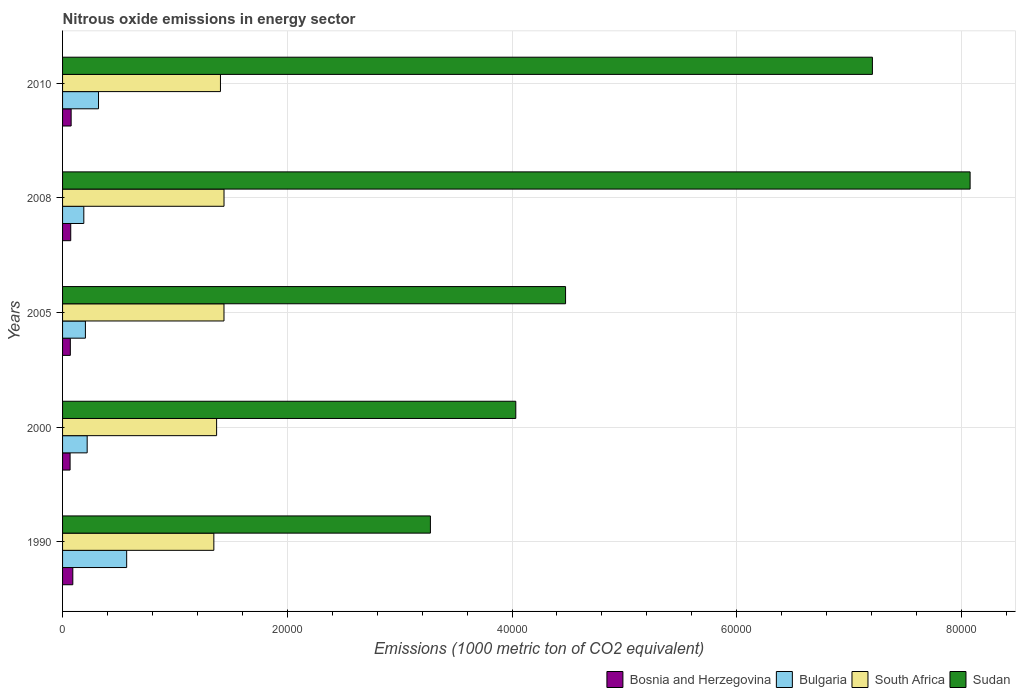Are the number of bars per tick equal to the number of legend labels?
Give a very brief answer. Yes. In how many cases, is the number of bars for a given year not equal to the number of legend labels?
Keep it short and to the point. 0. What is the amount of nitrous oxide emitted in Bosnia and Herzegovina in 2000?
Make the answer very short. 669.3. Across all years, what is the maximum amount of nitrous oxide emitted in Bulgaria?
Provide a succinct answer. 5705.4. Across all years, what is the minimum amount of nitrous oxide emitted in South Africa?
Keep it short and to the point. 1.35e+04. In which year was the amount of nitrous oxide emitted in South Africa maximum?
Ensure brevity in your answer.  2008. What is the total amount of nitrous oxide emitted in South Africa in the graph?
Ensure brevity in your answer.  7.00e+04. What is the difference between the amount of nitrous oxide emitted in Sudan in 1990 and that in 2000?
Offer a terse response. -7600.6. What is the difference between the amount of nitrous oxide emitted in South Africa in 1990 and the amount of nitrous oxide emitted in Sudan in 2005?
Your answer should be very brief. -3.13e+04. What is the average amount of nitrous oxide emitted in South Africa per year?
Provide a short and direct response. 1.40e+04. In the year 1990, what is the difference between the amount of nitrous oxide emitted in South Africa and amount of nitrous oxide emitted in Sudan?
Keep it short and to the point. -1.93e+04. In how many years, is the amount of nitrous oxide emitted in Sudan greater than 64000 1000 metric ton?
Give a very brief answer. 2. What is the ratio of the amount of nitrous oxide emitted in South Africa in 1990 to that in 2005?
Give a very brief answer. 0.94. What is the difference between the highest and the second highest amount of nitrous oxide emitted in Sudan?
Give a very brief answer. 8696.2. What is the difference between the highest and the lowest amount of nitrous oxide emitted in Bosnia and Herzegovina?
Your response must be concise. 242.9. Is the sum of the amount of nitrous oxide emitted in Bulgaria in 2008 and 2010 greater than the maximum amount of nitrous oxide emitted in Sudan across all years?
Your answer should be compact. No. What does the 2nd bar from the top in 2000 represents?
Provide a short and direct response. South Africa. How many bars are there?
Offer a terse response. 20. How many years are there in the graph?
Provide a succinct answer. 5. What is the difference between two consecutive major ticks on the X-axis?
Offer a very short reply. 2.00e+04. Are the values on the major ticks of X-axis written in scientific E-notation?
Make the answer very short. No. Does the graph contain any zero values?
Offer a terse response. No. Does the graph contain grids?
Give a very brief answer. Yes. How many legend labels are there?
Your answer should be very brief. 4. How are the legend labels stacked?
Give a very brief answer. Horizontal. What is the title of the graph?
Give a very brief answer. Nitrous oxide emissions in energy sector. What is the label or title of the X-axis?
Offer a very short reply. Emissions (1000 metric ton of CO2 equivalent). What is the Emissions (1000 metric ton of CO2 equivalent) of Bosnia and Herzegovina in 1990?
Make the answer very short. 912.2. What is the Emissions (1000 metric ton of CO2 equivalent) of Bulgaria in 1990?
Provide a succinct answer. 5705.4. What is the Emissions (1000 metric ton of CO2 equivalent) in South Africa in 1990?
Make the answer very short. 1.35e+04. What is the Emissions (1000 metric ton of CO2 equivalent) in Sudan in 1990?
Ensure brevity in your answer.  3.27e+04. What is the Emissions (1000 metric ton of CO2 equivalent) of Bosnia and Herzegovina in 2000?
Ensure brevity in your answer.  669.3. What is the Emissions (1000 metric ton of CO2 equivalent) of Bulgaria in 2000?
Provide a succinct answer. 2189.9. What is the Emissions (1000 metric ton of CO2 equivalent) in South Africa in 2000?
Offer a very short reply. 1.37e+04. What is the Emissions (1000 metric ton of CO2 equivalent) of Sudan in 2000?
Provide a short and direct response. 4.03e+04. What is the Emissions (1000 metric ton of CO2 equivalent) in Bosnia and Herzegovina in 2005?
Your response must be concise. 691.3. What is the Emissions (1000 metric ton of CO2 equivalent) of Bulgaria in 2005?
Give a very brief answer. 2033.5. What is the Emissions (1000 metric ton of CO2 equivalent) of South Africa in 2005?
Your answer should be very brief. 1.44e+04. What is the Emissions (1000 metric ton of CO2 equivalent) in Sudan in 2005?
Your response must be concise. 4.48e+04. What is the Emissions (1000 metric ton of CO2 equivalent) in Bosnia and Herzegovina in 2008?
Make the answer very short. 727.1. What is the Emissions (1000 metric ton of CO2 equivalent) of Bulgaria in 2008?
Offer a terse response. 1890.6. What is the Emissions (1000 metric ton of CO2 equivalent) in South Africa in 2008?
Provide a succinct answer. 1.44e+04. What is the Emissions (1000 metric ton of CO2 equivalent) of Sudan in 2008?
Your answer should be compact. 8.08e+04. What is the Emissions (1000 metric ton of CO2 equivalent) in Bosnia and Herzegovina in 2010?
Offer a very short reply. 762.6. What is the Emissions (1000 metric ton of CO2 equivalent) in Bulgaria in 2010?
Make the answer very short. 3199.8. What is the Emissions (1000 metric ton of CO2 equivalent) in South Africa in 2010?
Offer a terse response. 1.41e+04. What is the Emissions (1000 metric ton of CO2 equivalent) of Sudan in 2010?
Give a very brief answer. 7.21e+04. Across all years, what is the maximum Emissions (1000 metric ton of CO2 equivalent) of Bosnia and Herzegovina?
Offer a terse response. 912.2. Across all years, what is the maximum Emissions (1000 metric ton of CO2 equivalent) in Bulgaria?
Your answer should be very brief. 5705.4. Across all years, what is the maximum Emissions (1000 metric ton of CO2 equivalent) of South Africa?
Keep it short and to the point. 1.44e+04. Across all years, what is the maximum Emissions (1000 metric ton of CO2 equivalent) of Sudan?
Ensure brevity in your answer.  8.08e+04. Across all years, what is the minimum Emissions (1000 metric ton of CO2 equivalent) in Bosnia and Herzegovina?
Give a very brief answer. 669.3. Across all years, what is the minimum Emissions (1000 metric ton of CO2 equivalent) of Bulgaria?
Provide a succinct answer. 1890.6. Across all years, what is the minimum Emissions (1000 metric ton of CO2 equivalent) in South Africa?
Your answer should be very brief. 1.35e+04. Across all years, what is the minimum Emissions (1000 metric ton of CO2 equivalent) of Sudan?
Your answer should be compact. 3.27e+04. What is the total Emissions (1000 metric ton of CO2 equivalent) of Bosnia and Herzegovina in the graph?
Provide a succinct answer. 3762.5. What is the total Emissions (1000 metric ton of CO2 equivalent) in Bulgaria in the graph?
Give a very brief answer. 1.50e+04. What is the total Emissions (1000 metric ton of CO2 equivalent) in South Africa in the graph?
Provide a short and direct response. 7.00e+04. What is the total Emissions (1000 metric ton of CO2 equivalent) of Sudan in the graph?
Make the answer very short. 2.71e+05. What is the difference between the Emissions (1000 metric ton of CO2 equivalent) in Bosnia and Herzegovina in 1990 and that in 2000?
Provide a short and direct response. 242.9. What is the difference between the Emissions (1000 metric ton of CO2 equivalent) of Bulgaria in 1990 and that in 2000?
Your answer should be very brief. 3515.5. What is the difference between the Emissions (1000 metric ton of CO2 equivalent) in South Africa in 1990 and that in 2000?
Offer a very short reply. -246.5. What is the difference between the Emissions (1000 metric ton of CO2 equivalent) in Sudan in 1990 and that in 2000?
Offer a very short reply. -7600.6. What is the difference between the Emissions (1000 metric ton of CO2 equivalent) in Bosnia and Herzegovina in 1990 and that in 2005?
Offer a very short reply. 220.9. What is the difference between the Emissions (1000 metric ton of CO2 equivalent) in Bulgaria in 1990 and that in 2005?
Give a very brief answer. 3671.9. What is the difference between the Emissions (1000 metric ton of CO2 equivalent) in South Africa in 1990 and that in 2005?
Give a very brief answer. -903.7. What is the difference between the Emissions (1000 metric ton of CO2 equivalent) in Sudan in 1990 and that in 2005?
Offer a terse response. -1.20e+04. What is the difference between the Emissions (1000 metric ton of CO2 equivalent) in Bosnia and Herzegovina in 1990 and that in 2008?
Your answer should be very brief. 185.1. What is the difference between the Emissions (1000 metric ton of CO2 equivalent) of Bulgaria in 1990 and that in 2008?
Provide a succinct answer. 3814.8. What is the difference between the Emissions (1000 metric ton of CO2 equivalent) in South Africa in 1990 and that in 2008?
Offer a terse response. -905.7. What is the difference between the Emissions (1000 metric ton of CO2 equivalent) of Sudan in 1990 and that in 2008?
Your answer should be very brief. -4.80e+04. What is the difference between the Emissions (1000 metric ton of CO2 equivalent) of Bosnia and Herzegovina in 1990 and that in 2010?
Keep it short and to the point. 149.6. What is the difference between the Emissions (1000 metric ton of CO2 equivalent) in Bulgaria in 1990 and that in 2010?
Your response must be concise. 2505.6. What is the difference between the Emissions (1000 metric ton of CO2 equivalent) of South Africa in 1990 and that in 2010?
Keep it short and to the point. -588.2. What is the difference between the Emissions (1000 metric ton of CO2 equivalent) of Sudan in 1990 and that in 2010?
Provide a short and direct response. -3.93e+04. What is the difference between the Emissions (1000 metric ton of CO2 equivalent) in Bulgaria in 2000 and that in 2005?
Provide a succinct answer. 156.4. What is the difference between the Emissions (1000 metric ton of CO2 equivalent) in South Africa in 2000 and that in 2005?
Your response must be concise. -657.2. What is the difference between the Emissions (1000 metric ton of CO2 equivalent) of Sudan in 2000 and that in 2005?
Your response must be concise. -4429.1. What is the difference between the Emissions (1000 metric ton of CO2 equivalent) of Bosnia and Herzegovina in 2000 and that in 2008?
Offer a very short reply. -57.8. What is the difference between the Emissions (1000 metric ton of CO2 equivalent) of Bulgaria in 2000 and that in 2008?
Your response must be concise. 299.3. What is the difference between the Emissions (1000 metric ton of CO2 equivalent) of South Africa in 2000 and that in 2008?
Offer a terse response. -659.2. What is the difference between the Emissions (1000 metric ton of CO2 equivalent) of Sudan in 2000 and that in 2008?
Offer a very short reply. -4.04e+04. What is the difference between the Emissions (1000 metric ton of CO2 equivalent) in Bosnia and Herzegovina in 2000 and that in 2010?
Your response must be concise. -93.3. What is the difference between the Emissions (1000 metric ton of CO2 equivalent) of Bulgaria in 2000 and that in 2010?
Your response must be concise. -1009.9. What is the difference between the Emissions (1000 metric ton of CO2 equivalent) of South Africa in 2000 and that in 2010?
Provide a short and direct response. -341.7. What is the difference between the Emissions (1000 metric ton of CO2 equivalent) of Sudan in 2000 and that in 2010?
Ensure brevity in your answer.  -3.17e+04. What is the difference between the Emissions (1000 metric ton of CO2 equivalent) of Bosnia and Herzegovina in 2005 and that in 2008?
Ensure brevity in your answer.  -35.8. What is the difference between the Emissions (1000 metric ton of CO2 equivalent) of Bulgaria in 2005 and that in 2008?
Ensure brevity in your answer.  142.9. What is the difference between the Emissions (1000 metric ton of CO2 equivalent) of South Africa in 2005 and that in 2008?
Keep it short and to the point. -2. What is the difference between the Emissions (1000 metric ton of CO2 equivalent) of Sudan in 2005 and that in 2008?
Ensure brevity in your answer.  -3.60e+04. What is the difference between the Emissions (1000 metric ton of CO2 equivalent) in Bosnia and Herzegovina in 2005 and that in 2010?
Provide a succinct answer. -71.3. What is the difference between the Emissions (1000 metric ton of CO2 equivalent) in Bulgaria in 2005 and that in 2010?
Your answer should be very brief. -1166.3. What is the difference between the Emissions (1000 metric ton of CO2 equivalent) of South Africa in 2005 and that in 2010?
Your response must be concise. 315.5. What is the difference between the Emissions (1000 metric ton of CO2 equivalent) of Sudan in 2005 and that in 2010?
Your answer should be compact. -2.73e+04. What is the difference between the Emissions (1000 metric ton of CO2 equivalent) of Bosnia and Herzegovina in 2008 and that in 2010?
Give a very brief answer. -35.5. What is the difference between the Emissions (1000 metric ton of CO2 equivalent) of Bulgaria in 2008 and that in 2010?
Give a very brief answer. -1309.2. What is the difference between the Emissions (1000 metric ton of CO2 equivalent) in South Africa in 2008 and that in 2010?
Provide a short and direct response. 317.5. What is the difference between the Emissions (1000 metric ton of CO2 equivalent) in Sudan in 2008 and that in 2010?
Your answer should be very brief. 8696.2. What is the difference between the Emissions (1000 metric ton of CO2 equivalent) in Bosnia and Herzegovina in 1990 and the Emissions (1000 metric ton of CO2 equivalent) in Bulgaria in 2000?
Offer a terse response. -1277.7. What is the difference between the Emissions (1000 metric ton of CO2 equivalent) in Bosnia and Herzegovina in 1990 and the Emissions (1000 metric ton of CO2 equivalent) in South Africa in 2000?
Keep it short and to the point. -1.28e+04. What is the difference between the Emissions (1000 metric ton of CO2 equivalent) in Bosnia and Herzegovina in 1990 and the Emissions (1000 metric ton of CO2 equivalent) in Sudan in 2000?
Your answer should be very brief. -3.94e+04. What is the difference between the Emissions (1000 metric ton of CO2 equivalent) of Bulgaria in 1990 and the Emissions (1000 metric ton of CO2 equivalent) of South Africa in 2000?
Make the answer very short. -8004.5. What is the difference between the Emissions (1000 metric ton of CO2 equivalent) in Bulgaria in 1990 and the Emissions (1000 metric ton of CO2 equivalent) in Sudan in 2000?
Your response must be concise. -3.46e+04. What is the difference between the Emissions (1000 metric ton of CO2 equivalent) in South Africa in 1990 and the Emissions (1000 metric ton of CO2 equivalent) in Sudan in 2000?
Keep it short and to the point. -2.69e+04. What is the difference between the Emissions (1000 metric ton of CO2 equivalent) of Bosnia and Herzegovina in 1990 and the Emissions (1000 metric ton of CO2 equivalent) of Bulgaria in 2005?
Ensure brevity in your answer.  -1121.3. What is the difference between the Emissions (1000 metric ton of CO2 equivalent) in Bosnia and Herzegovina in 1990 and the Emissions (1000 metric ton of CO2 equivalent) in South Africa in 2005?
Your answer should be very brief. -1.35e+04. What is the difference between the Emissions (1000 metric ton of CO2 equivalent) in Bosnia and Herzegovina in 1990 and the Emissions (1000 metric ton of CO2 equivalent) in Sudan in 2005?
Offer a very short reply. -4.39e+04. What is the difference between the Emissions (1000 metric ton of CO2 equivalent) of Bulgaria in 1990 and the Emissions (1000 metric ton of CO2 equivalent) of South Africa in 2005?
Give a very brief answer. -8661.7. What is the difference between the Emissions (1000 metric ton of CO2 equivalent) of Bulgaria in 1990 and the Emissions (1000 metric ton of CO2 equivalent) of Sudan in 2005?
Your answer should be very brief. -3.91e+04. What is the difference between the Emissions (1000 metric ton of CO2 equivalent) of South Africa in 1990 and the Emissions (1000 metric ton of CO2 equivalent) of Sudan in 2005?
Keep it short and to the point. -3.13e+04. What is the difference between the Emissions (1000 metric ton of CO2 equivalent) of Bosnia and Herzegovina in 1990 and the Emissions (1000 metric ton of CO2 equivalent) of Bulgaria in 2008?
Your answer should be very brief. -978.4. What is the difference between the Emissions (1000 metric ton of CO2 equivalent) in Bosnia and Herzegovina in 1990 and the Emissions (1000 metric ton of CO2 equivalent) in South Africa in 2008?
Provide a succinct answer. -1.35e+04. What is the difference between the Emissions (1000 metric ton of CO2 equivalent) of Bosnia and Herzegovina in 1990 and the Emissions (1000 metric ton of CO2 equivalent) of Sudan in 2008?
Give a very brief answer. -7.99e+04. What is the difference between the Emissions (1000 metric ton of CO2 equivalent) in Bulgaria in 1990 and the Emissions (1000 metric ton of CO2 equivalent) in South Africa in 2008?
Offer a terse response. -8663.7. What is the difference between the Emissions (1000 metric ton of CO2 equivalent) in Bulgaria in 1990 and the Emissions (1000 metric ton of CO2 equivalent) in Sudan in 2008?
Your answer should be compact. -7.51e+04. What is the difference between the Emissions (1000 metric ton of CO2 equivalent) of South Africa in 1990 and the Emissions (1000 metric ton of CO2 equivalent) of Sudan in 2008?
Provide a succinct answer. -6.73e+04. What is the difference between the Emissions (1000 metric ton of CO2 equivalent) in Bosnia and Herzegovina in 1990 and the Emissions (1000 metric ton of CO2 equivalent) in Bulgaria in 2010?
Give a very brief answer. -2287.6. What is the difference between the Emissions (1000 metric ton of CO2 equivalent) in Bosnia and Herzegovina in 1990 and the Emissions (1000 metric ton of CO2 equivalent) in South Africa in 2010?
Provide a succinct answer. -1.31e+04. What is the difference between the Emissions (1000 metric ton of CO2 equivalent) of Bosnia and Herzegovina in 1990 and the Emissions (1000 metric ton of CO2 equivalent) of Sudan in 2010?
Your answer should be compact. -7.12e+04. What is the difference between the Emissions (1000 metric ton of CO2 equivalent) of Bulgaria in 1990 and the Emissions (1000 metric ton of CO2 equivalent) of South Africa in 2010?
Provide a short and direct response. -8346.2. What is the difference between the Emissions (1000 metric ton of CO2 equivalent) of Bulgaria in 1990 and the Emissions (1000 metric ton of CO2 equivalent) of Sudan in 2010?
Your answer should be very brief. -6.64e+04. What is the difference between the Emissions (1000 metric ton of CO2 equivalent) in South Africa in 1990 and the Emissions (1000 metric ton of CO2 equivalent) in Sudan in 2010?
Your response must be concise. -5.86e+04. What is the difference between the Emissions (1000 metric ton of CO2 equivalent) in Bosnia and Herzegovina in 2000 and the Emissions (1000 metric ton of CO2 equivalent) in Bulgaria in 2005?
Your response must be concise. -1364.2. What is the difference between the Emissions (1000 metric ton of CO2 equivalent) in Bosnia and Herzegovina in 2000 and the Emissions (1000 metric ton of CO2 equivalent) in South Africa in 2005?
Your answer should be compact. -1.37e+04. What is the difference between the Emissions (1000 metric ton of CO2 equivalent) of Bosnia and Herzegovina in 2000 and the Emissions (1000 metric ton of CO2 equivalent) of Sudan in 2005?
Offer a very short reply. -4.41e+04. What is the difference between the Emissions (1000 metric ton of CO2 equivalent) of Bulgaria in 2000 and the Emissions (1000 metric ton of CO2 equivalent) of South Africa in 2005?
Make the answer very short. -1.22e+04. What is the difference between the Emissions (1000 metric ton of CO2 equivalent) of Bulgaria in 2000 and the Emissions (1000 metric ton of CO2 equivalent) of Sudan in 2005?
Provide a succinct answer. -4.26e+04. What is the difference between the Emissions (1000 metric ton of CO2 equivalent) of South Africa in 2000 and the Emissions (1000 metric ton of CO2 equivalent) of Sudan in 2005?
Provide a short and direct response. -3.11e+04. What is the difference between the Emissions (1000 metric ton of CO2 equivalent) in Bosnia and Herzegovina in 2000 and the Emissions (1000 metric ton of CO2 equivalent) in Bulgaria in 2008?
Provide a succinct answer. -1221.3. What is the difference between the Emissions (1000 metric ton of CO2 equivalent) in Bosnia and Herzegovina in 2000 and the Emissions (1000 metric ton of CO2 equivalent) in South Africa in 2008?
Your answer should be compact. -1.37e+04. What is the difference between the Emissions (1000 metric ton of CO2 equivalent) of Bosnia and Herzegovina in 2000 and the Emissions (1000 metric ton of CO2 equivalent) of Sudan in 2008?
Offer a very short reply. -8.01e+04. What is the difference between the Emissions (1000 metric ton of CO2 equivalent) in Bulgaria in 2000 and the Emissions (1000 metric ton of CO2 equivalent) in South Africa in 2008?
Ensure brevity in your answer.  -1.22e+04. What is the difference between the Emissions (1000 metric ton of CO2 equivalent) in Bulgaria in 2000 and the Emissions (1000 metric ton of CO2 equivalent) in Sudan in 2008?
Keep it short and to the point. -7.86e+04. What is the difference between the Emissions (1000 metric ton of CO2 equivalent) in South Africa in 2000 and the Emissions (1000 metric ton of CO2 equivalent) in Sudan in 2008?
Offer a very short reply. -6.71e+04. What is the difference between the Emissions (1000 metric ton of CO2 equivalent) of Bosnia and Herzegovina in 2000 and the Emissions (1000 metric ton of CO2 equivalent) of Bulgaria in 2010?
Provide a succinct answer. -2530.5. What is the difference between the Emissions (1000 metric ton of CO2 equivalent) in Bosnia and Herzegovina in 2000 and the Emissions (1000 metric ton of CO2 equivalent) in South Africa in 2010?
Keep it short and to the point. -1.34e+04. What is the difference between the Emissions (1000 metric ton of CO2 equivalent) of Bosnia and Herzegovina in 2000 and the Emissions (1000 metric ton of CO2 equivalent) of Sudan in 2010?
Your response must be concise. -7.14e+04. What is the difference between the Emissions (1000 metric ton of CO2 equivalent) in Bulgaria in 2000 and the Emissions (1000 metric ton of CO2 equivalent) in South Africa in 2010?
Make the answer very short. -1.19e+04. What is the difference between the Emissions (1000 metric ton of CO2 equivalent) in Bulgaria in 2000 and the Emissions (1000 metric ton of CO2 equivalent) in Sudan in 2010?
Make the answer very short. -6.99e+04. What is the difference between the Emissions (1000 metric ton of CO2 equivalent) of South Africa in 2000 and the Emissions (1000 metric ton of CO2 equivalent) of Sudan in 2010?
Your answer should be very brief. -5.84e+04. What is the difference between the Emissions (1000 metric ton of CO2 equivalent) in Bosnia and Herzegovina in 2005 and the Emissions (1000 metric ton of CO2 equivalent) in Bulgaria in 2008?
Provide a succinct answer. -1199.3. What is the difference between the Emissions (1000 metric ton of CO2 equivalent) in Bosnia and Herzegovina in 2005 and the Emissions (1000 metric ton of CO2 equivalent) in South Africa in 2008?
Keep it short and to the point. -1.37e+04. What is the difference between the Emissions (1000 metric ton of CO2 equivalent) of Bosnia and Herzegovina in 2005 and the Emissions (1000 metric ton of CO2 equivalent) of Sudan in 2008?
Offer a terse response. -8.01e+04. What is the difference between the Emissions (1000 metric ton of CO2 equivalent) in Bulgaria in 2005 and the Emissions (1000 metric ton of CO2 equivalent) in South Africa in 2008?
Provide a short and direct response. -1.23e+04. What is the difference between the Emissions (1000 metric ton of CO2 equivalent) in Bulgaria in 2005 and the Emissions (1000 metric ton of CO2 equivalent) in Sudan in 2008?
Offer a terse response. -7.87e+04. What is the difference between the Emissions (1000 metric ton of CO2 equivalent) in South Africa in 2005 and the Emissions (1000 metric ton of CO2 equivalent) in Sudan in 2008?
Provide a succinct answer. -6.64e+04. What is the difference between the Emissions (1000 metric ton of CO2 equivalent) in Bosnia and Herzegovina in 2005 and the Emissions (1000 metric ton of CO2 equivalent) in Bulgaria in 2010?
Make the answer very short. -2508.5. What is the difference between the Emissions (1000 metric ton of CO2 equivalent) in Bosnia and Herzegovina in 2005 and the Emissions (1000 metric ton of CO2 equivalent) in South Africa in 2010?
Offer a terse response. -1.34e+04. What is the difference between the Emissions (1000 metric ton of CO2 equivalent) in Bosnia and Herzegovina in 2005 and the Emissions (1000 metric ton of CO2 equivalent) in Sudan in 2010?
Offer a very short reply. -7.14e+04. What is the difference between the Emissions (1000 metric ton of CO2 equivalent) in Bulgaria in 2005 and the Emissions (1000 metric ton of CO2 equivalent) in South Africa in 2010?
Your answer should be compact. -1.20e+04. What is the difference between the Emissions (1000 metric ton of CO2 equivalent) in Bulgaria in 2005 and the Emissions (1000 metric ton of CO2 equivalent) in Sudan in 2010?
Make the answer very short. -7.00e+04. What is the difference between the Emissions (1000 metric ton of CO2 equivalent) of South Africa in 2005 and the Emissions (1000 metric ton of CO2 equivalent) of Sudan in 2010?
Ensure brevity in your answer.  -5.77e+04. What is the difference between the Emissions (1000 metric ton of CO2 equivalent) in Bosnia and Herzegovina in 2008 and the Emissions (1000 metric ton of CO2 equivalent) in Bulgaria in 2010?
Offer a terse response. -2472.7. What is the difference between the Emissions (1000 metric ton of CO2 equivalent) of Bosnia and Herzegovina in 2008 and the Emissions (1000 metric ton of CO2 equivalent) of South Africa in 2010?
Make the answer very short. -1.33e+04. What is the difference between the Emissions (1000 metric ton of CO2 equivalent) of Bosnia and Herzegovina in 2008 and the Emissions (1000 metric ton of CO2 equivalent) of Sudan in 2010?
Ensure brevity in your answer.  -7.14e+04. What is the difference between the Emissions (1000 metric ton of CO2 equivalent) in Bulgaria in 2008 and the Emissions (1000 metric ton of CO2 equivalent) in South Africa in 2010?
Your answer should be very brief. -1.22e+04. What is the difference between the Emissions (1000 metric ton of CO2 equivalent) in Bulgaria in 2008 and the Emissions (1000 metric ton of CO2 equivalent) in Sudan in 2010?
Your response must be concise. -7.02e+04. What is the difference between the Emissions (1000 metric ton of CO2 equivalent) of South Africa in 2008 and the Emissions (1000 metric ton of CO2 equivalent) of Sudan in 2010?
Your response must be concise. -5.77e+04. What is the average Emissions (1000 metric ton of CO2 equivalent) in Bosnia and Herzegovina per year?
Give a very brief answer. 752.5. What is the average Emissions (1000 metric ton of CO2 equivalent) of Bulgaria per year?
Give a very brief answer. 3003.84. What is the average Emissions (1000 metric ton of CO2 equivalent) of South Africa per year?
Ensure brevity in your answer.  1.40e+04. What is the average Emissions (1000 metric ton of CO2 equivalent) in Sudan per year?
Your response must be concise. 5.41e+04. In the year 1990, what is the difference between the Emissions (1000 metric ton of CO2 equivalent) in Bosnia and Herzegovina and Emissions (1000 metric ton of CO2 equivalent) in Bulgaria?
Make the answer very short. -4793.2. In the year 1990, what is the difference between the Emissions (1000 metric ton of CO2 equivalent) of Bosnia and Herzegovina and Emissions (1000 metric ton of CO2 equivalent) of South Africa?
Your response must be concise. -1.26e+04. In the year 1990, what is the difference between the Emissions (1000 metric ton of CO2 equivalent) of Bosnia and Herzegovina and Emissions (1000 metric ton of CO2 equivalent) of Sudan?
Ensure brevity in your answer.  -3.18e+04. In the year 1990, what is the difference between the Emissions (1000 metric ton of CO2 equivalent) of Bulgaria and Emissions (1000 metric ton of CO2 equivalent) of South Africa?
Provide a short and direct response. -7758. In the year 1990, what is the difference between the Emissions (1000 metric ton of CO2 equivalent) in Bulgaria and Emissions (1000 metric ton of CO2 equivalent) in Sudan?
Give a very brief answer. -2.70e+04. In the year 1990, what is the difference between the Emissions (1000 metric ton of CO2 equivalent) of South Africa and Emissions (1000 metric ton of CO2 equivalent) of Sudan?
Your answer should be compact. -1.93e+04. In the year 2000, what is the difference between the Emissions (1000 metric ton of CO2 equivalent) in Bosnia and Herzegovina and Emissions (1000 metric ton of CO2 equivalent) in Bulgaria?
Make the answer very short. -1520.6. In the year 2000, what is the difference between the Emissions (1000 metric ton of CO2 equivalent) of Bosnia and Herzegovina and Emissions (1000 metric ton of CO2 equivalent) of South Africa?
Your answer should be very brief. -1.30e+04. In the year 2000, what is the difference between the Emissions (1000 metric ton of CO2 equivalent) of Bosnia and Herzegovina and Emissions (1000 metric ton of CO2 equivalent) of Sudan?
Give a very brief answer. -3.97e+04. In the year 2000, what is the difference between the Emissions (1000 metric ton of CO2 equivalent) in Bulgaria and Emissions (1000 metric ton of CO2 equivalent) in South Africa?
Keep it short and to the point. -1.15e+04. In the year 2000, what is the difference between the Emissions (1000 metric ton of CO2 equivalent) of Bulgaria and Emissions (1000 metric ton of CO2 equivalent) of Sudan?
Offer a very short reply. -3.81e+04. In the year 2000, what is the difference between the Emissions (1000 metric ton of CO2 equivalent) in South Africa and Emissions (1000 metric ton of CO2 equivalent) in Sudan?
Provide a short and direct response. -2.66e+04. In the year 2005, what is the difference between the Emissions (1000 metric ton of CO2 equivalent) in Bosnia and Herzegovina and Emissions (1000 metric ton of CO2 equivalent) in Bulgaria?
Provide a short and direct response. -1342.2. In the year 2005, what is the difference between the Emissions (1000 metric ton of CO2 equivalent) of Bosnia and Herzegovina and Emissions (1000 metric ton of CO2 equivalent) of South Africa?
Your response must be concise. -1.37e+04. In the year 2005, what is the difference between the Emissions (1000 metric ton of CO2 equivalent) of Bosnia and Herzegovina and Emissions (1000 metric ton of CO2 equivalent) of Sudan?
Your answer should be very brief. -4.41e+04. In the year 2005, what is the difference between the Emissions (1000 metric ton of CO2 equivalent) in Bulgaria and Emissions (1000 metric ton of CO2 equivalent) in South Africa?
Give a very brief answer. -1.23e+04. In the year 2005, what is the difference between the Emissions (1000 metric ton of CO2 equivalent) of Bulgaria and Emissions (1000 metric ton of CO2 equivalent) of Sudan?
Ensure brevity in your answer.  -4.27e+04. In the year 2005, what is the difference between the Emissions (1000 metric ton of CO2 equivalent) in South Africa and Emissions (1000 metric ton of CO2 equivalent) in Sudan?
Make the answer very short. -3.04e+04. In the year 2008, what is the difference between the Emissions (1000 metric ton of CO2 equivalent) in Bosnia and Herzegovina and Emissions (1000 metric ton of CO2 equivalent) in Bulgaria?
Keep it short and to the point. -1163.5. In the year 2008, what is the difference between the Emissions (1000 metric ton of CO2 equivalent) in Bosnia and Herzegovina and Emissions (1000 metric ton of CO2 equivalent) in South Africa?
Your answer should be very brief. -1.36e+04. In the year 2008, what is the difference between the Emissions (1000 metric ton of CO2 equivalent) of Bosnia and Herzegovina and Emissions (1000 metric ton of CO2 equivalent) of Sudan?
Your response must be concise. -8.00e+04. In the year 2008, what is the difference between the Emissions (1000 metric ton of CO2 equivalent) in Bulgaria and Emissions (1000 metric ton of CO2 equivalent) in South Africa?
Offer a very short reply. -1.25e+04. In the year 2008, what is the difference between the Emissions (1000 metric ton of CO2 equivalent) in Bulgaria and Emissions (1000 metric ton of CO2 equivalent) in Sudan?
Offer a terse response. -7.89e+04. In the year 2008, what is the difference between the Emissions (1000 metric ton of CO2 equivalent) of South Africa and Emissions (1000 metric ton of CO2 equivalent) of Sudan?
Keep it short and to the point. -6.64e+04. In the year 2010, what is the difference between the Emissions (1000 metric ton of CO2 equivalent) in Bosnia and Herzegovina and Emissions (1000 metric ton of CO2 equivalent) in Bulgaria?
Offer a very short reply. -2437.2. In the year 2010, what is the difference between the Emissions (1000 metric ton of CO2 equivalent) of Bosnia and Herzegovina and Emissions (1000 metric ton of CO2 equivalent) of South Africa?
Offer a very short reply. -1.33e+04. In the year 2010, what is the difference between the Emissions (1000 metric ton of CO2 equivalent) in Bosnia and Herzegovina and Emissions (1000 metric ton of CO2 equivalent) in Sudan?
Your response must be concise. -7.13e+04. In the year 2010, what is the difference between the Emissions (1000 metric ton of CO2 equivalent) in Bulgaria and Emissions (1000 metric ton of CO2 equivalent) in South Africa?
Keep it short and to the point. -1.09e+04. In the year 2010, what is the difference between the Emissions (1000 metric ton of CO2 equivalent) in Bulgaria and Emissions (1000 metric ton of CO2 equivalent) in Sudan?
Offer a very short reply. -6.89e+04. In the year 2010, what is the difference between the Emissions (1000 metric ton of CO2 equivalent) in South Africa and Emissions (1000 metric ton of CO2 equivalent) in Sudan?
Ensure brevity in your answer.  -5.80e+04. What is the ratio of the Emissions (1000 metric ton of CO2 equivalent) in Bosnia and Herzegovina in 1990 to that in 2000?
Make the answer very short. 1.36. What is the ratio of the Emissions (1000 metric ton of CO2 equivalent) in Bulgaria in 1990 to that in 2000?
Provide a short and direct response. 2.61. What is the ratio of the Emissions (1000 metric ton of CO2 equivalent) of South Africa in 1990 to that in 2000?
Offer a terse response. 0.98. What is the ratio of the Emissions (1000 metric ton of CO2 equivalent) in Sudan in 1990 to that in 2000?
Your answer should be very brief. 0.81. What is the ratio of the Emissions (1000 metric ton of CO2 equivalent) in Bosnia and Herzegovina in 1990 to that in 2005?
Provide a succinct answer. 1.32. What is the ratio of the Emissions (1000 metric ton of CO2 equivalent) of Bulgaria in 1990 to that in 2005?
Offer a terse response. 2.81. What is the ratio of the Emissions (1000 metric ton of CO2 equivalent) of South Africa in 1990 to that in 2005?
Offer a very short reply. 0.94. What is the ratio of the Emissions (1000 metric ton of CO2 equivalent) in Sudan in 1990 to that in 2005?
Keep it short and to the point. 0.73. What is the ratio of the Emissions (1000 metric ton of CO2 equivalent) of Bosnia and Herzegovina in 1990 to that in 2008?
Your answer should be very brief. 1.25. What is the ratio of the Emissions (1000 metric ton of CO2 equivalent) in Bulgaria in 1990 to that in 2008?
Your response must be concise. 3.02. What is the ratio of the Emissions (1000 metric ton of CO2 equivalent) in South Africa in 1990 to that in 2008?
Provide a succinct answer. 0.94. What is the ratio of the Emissions (1000 metric ton of CO2 equivalent) in Sudan in 1990 to that in 2008?
Offer a terse response. 0.41. What is the ratio of the Emissions (1000 metric ton of CO2 equivalent) of Bosnia and Herzegovina in 1990 to that in 2010?
Offer a terse response. 1.2. What is the ratio of the Emissions (1000 metric ton of CO2 equivalent) of Bulgaria in 1990 to that in 2010?
Provide a succinct answer. 1.78. What is the ratio of the Emissions (1000 metric ton of CO2 equivalent) in South Africa in 1990 to that in 2010?
Give a very brief answer. 0.96. What is the ratio of the Emissions (1000 metric ton of CO2 equivalent) of Sudan in 1990 to that in 2010?
Offer a terse response. 0.45. What is the ratio of the Emissions (1000 metric ton of CO2 equivalent) in Bosnia and Herzegovina in 2000 to that in 2005?
Your answer should be very brief. 0.97. What is the ratio of the Emissions (1000 metric ton of CO2 equivalent) in Bulgaria in 2000 to that in 2005?
Offer a very short reply. 1.08. What is the ratio of the Emissions (1000 metric ton of CO2 equivalent) in South Africa in 2000 to that in 2005?
Provide a succinct answer. 0.95. What is the ratio of the Emissions (1000 metric ton of CO2 equivalent) of Sudan in 2000 to that in 2005?
Ensure brevity in your answer.  0.9. What is the ratio of the Emissions (1000 metric ton of CO2 equivalent) of Bosnia and Herzegovina in 2000 to that in 2008?
Ensure brevity in your answer.  0.92. What is the ratio of the Emissions (1000 metric ton of CO2 equivalent) of Bulgaria in 2000 to that in 2008?
Provide a succinct answer. 1.16. What is the ratio of the Emissions (1000 metric ton of CO2 equivalent) in South Africa in 2000 to that in 2008?
Provide a succinct answer. 0.95. What is the ratio of the Emissions (1000 metric ton of CO2 equivalent) of Sudan in 2000 to that in 2008?
Your response must be concise. 0.5. What is the ratio of the Emissions (1000 metric ton of CO2 equivalent) of Bosnia and Herzegovina in 2000 to that in 2010?
Offer a terse response. 0.88. What is the ratio of the Emissions (1000 metric ton of CO2 equivalent) in Bulgaria in 2000 to that in 2010?
Make the answer very short. 0.68. What is the ratio of the Emissions (1000 metric ton of CO2 equivalent) in South Africa in 2000 to that in 2010?
Offer a very short reply. 0.98. What is the ratio of the Emissions (1000 metric ton of CO2 equivalent) in Sudan in 2000 to that in 2010?
Your answer should be compact. 0.56. What is the ratio of the Emissions (1000 metric ton of CO2 equivalent) in Bosnia and Herzegovina in 2005 to that in 2008?
Make the answer very short. 0.95. What is the ratio of the Emissions (1000 metric ton of CO2 equivalent) in Bulgaria in 2005 to that in 2008?
Keep it short and to the point. 1.08. What is the ratio of the Emissions (1000 metric ton of CO2 equivalent) of South Africa in 2005 to that in 2008?
Your answer should be compact. 1. What is the ratio of the Emissions (1000 metric ton of CO2 equivalent) of Sudan in 2005 to that in 2008?
Your answer should be compact. 0.55. What is the ratio of the Emissions (1000 metric ton of CO2 equivalent) of Bosnia and Herzegovina in 2005 to that in 2010?
Offer a very short reply. 0.91. What is the ratio of the Emissions (1000 metric ton of CO2 equivalent) in Bulgaria in 2005 to that in 2010?
Keep it short and to the point. 0.64. What is the ratio of the Emissions (1000 metric ton of CO2 equivalent) of South Africa in 2005 to that in 2010?
Your answer should be very brief. 1.02. What is the ratio of the Emissions (1000 metric ton of CO2 equivalent) in Sudan in 2005 to that in 2010?
Ensure brevity in your answer.  0.62. What is the ratio of the Emissions (1000 metric ton of CO2 equivalent) in Bosnia and Herzegovina in 2008 to that in 2010?
Your response must be concise. 0.95. What is the ratio of the Emissions (1000 metric ton of CO2 equivalent) of Bulgaria in 2008 to that in 2010?
Your response must be concise. 0.59. What is the ratio of the Emissions (1000 metric ton of CO2 equivalent) of South Africa in 2008 to that in 2010?
Your answer should be compact. 1.02. What is the ratio of the Emissions (1000 metric ton of CO2 equivalent) in Sudan in 2008 to that in 2010?
Make the answer very short. 1.12. What is the difference between the highest and the second highest Emissions (1000 metric ton of CO2 equivalent) in Bosnia and Herzegovina?
Offer a terse response. 149.6. What is the difference between the highest and the second highest Emissions (1000 metric ton of CO2 equivalent) of Bulgaria?
Provide a succinct answer. 2505.6. What is the difference between the highest and the second highest Emissions (1000 metric ton of CO2 equivalent) in South Africa?
Your answer should be compact. 2. What is the difference between the highest and the second highest Emissions (1000 metric ton of CO2 equivalent) of Sudan?
Make the answer very short. 8696.2. What is the difference between the highest and the lowest Emissions (1000 metric ton of CO2 equivalent) of Bosnia and Herzegovina?
Ensure brevity in your answer.  242.9. What is the difference between the highest and the lowest Emissions (1000 metric ton of CO2 equivalent) in Bulgaria?
Offer a terse response. 3814.8. What is the difference between the highest and the lowest Emissions (1000 metric ton of CO2 equivalent) in South Africa?
Provide a short and direct response. 905.7. What is the difference between the highest and the lowest Emissions (1000 metric ton of CO2 equivalent) of Sudan?
Keep it short and to the point. 4.80e+04. 